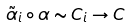Convert formula to latex. <formula><loc_0><loc_0><loc_500><loc_500>\tilde { \alpha } _ { i } \circ \alpha \sim C _ { i } \rightarrow C</formula> 